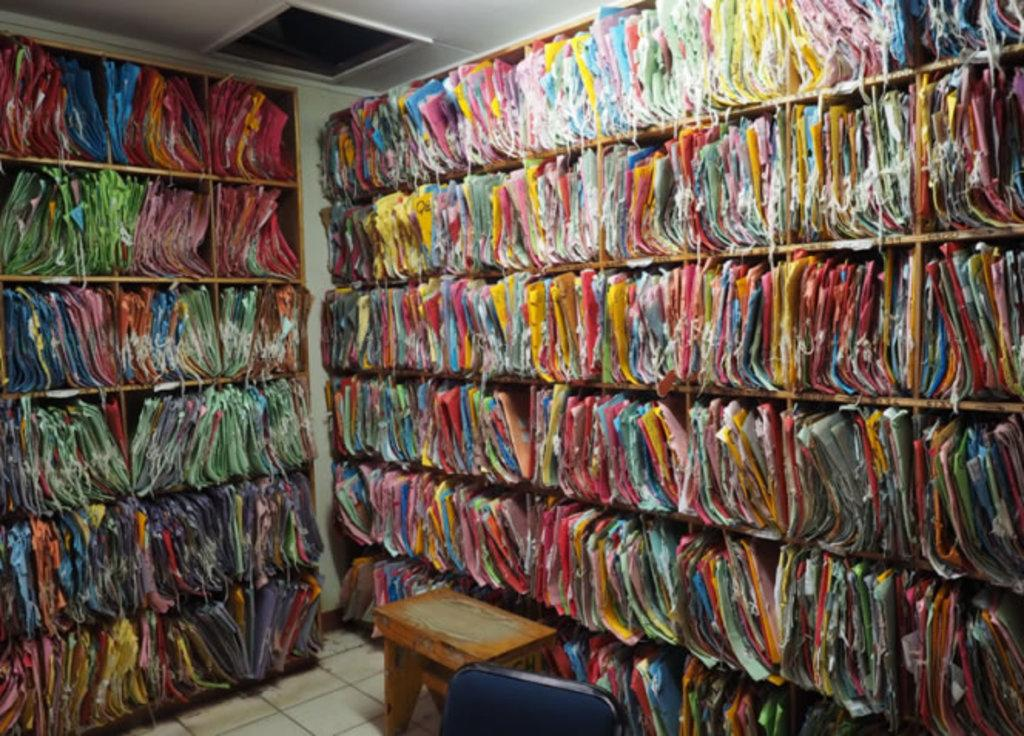What type of space is depicted in the image? The image is of a room. What can be found inside the cupboard in the room? There are bags in the cupboard. What is the source of light in the room? There is a light at the top of the room. What type of furniture is located at the bottom of the room? There is a stool and a chair at the bottom of the room. How does the fact join the tramp in the image? There is no fact or tramp present in the image; it is a room with bags, a light, a stool, and a chair. 